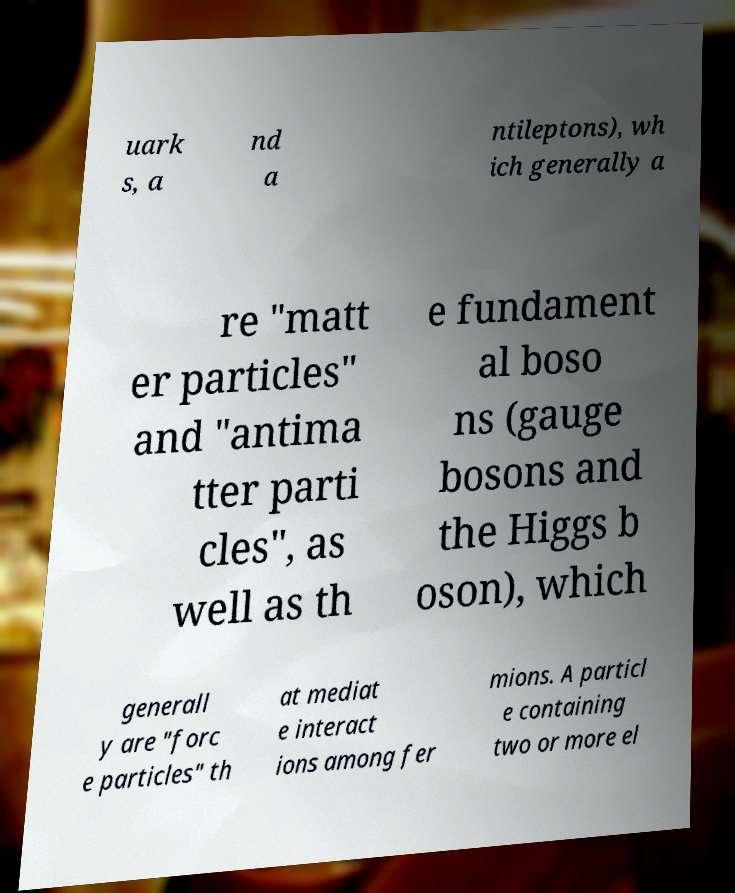Could you assist in decoding the text presented in this image and type it out clearly? uark s, a nd a ntileptons), wh ich generally a re "matt er particles" and "antima tter parti cles", as well as th e fundament al boso ns (gauge bosons and the Higgs b oson), which generall y are "forc e particles" th at mediat e interact ions among fer mions. A particl e containing two or more el 